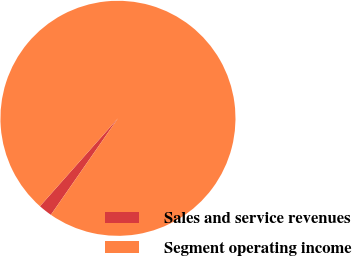<chart> <loc_0><loc_0><loc_500><loc_500><pie_chart><fcel>Sales and service revenues<fcel>Segment operating income<nl><fcel>1.88%<fcel>98.12%<nl></chart> 